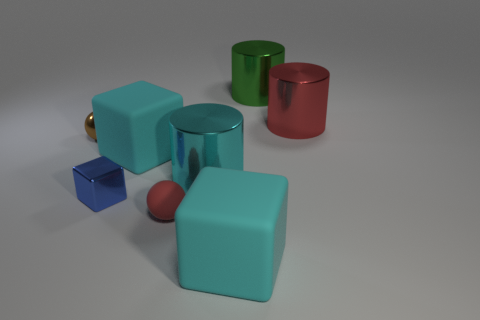Add 2 big cylinders. How many objects exist? 10 Subtract all cylinders. How many objects are left? 5 Add 5 big blue cylinders. How many big blue cylinders exist? 5 Subtract 0 blue spheres. How many objects are left? 8 Subtract all big red metal objects. Subtract all tiny shiny spheres. How many objects are left? 6 Add 2 big red things. How many big red things are left? 3 